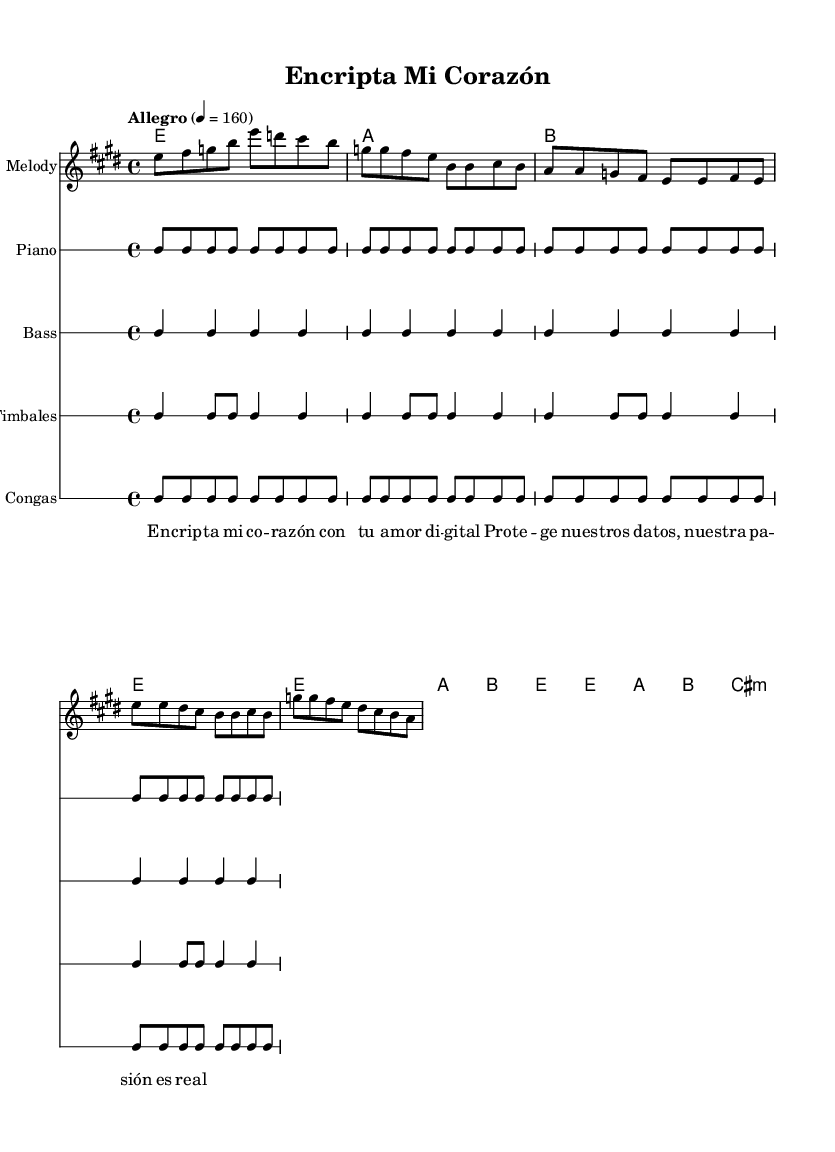What is the key signature of this music? The key signature is shown at the beginning of the piece and indicates E major, which has four sharps.
Answer: E major What is the time signature of the piece? The time signature is located at the start of the music, displaying a '4/4' meaning there are four beats in each measure and the quarter note gets one beat.
Answer: 4/4 What is the tempo marking given for this piece? The tempo marking is found at the beginning, under the header, indicated by "Allegro" and a metronome marking of "4 = 160," which suggests it should be played fast.
Answer: Allegro 4 = 160 How many measures are in the chorus? The chorus section is marked and can be counted from the notation provided; it consists of two measures.
Answer: 2 What type of rhythm is utilized for the congas? The rhythm for the congas is defined in the rhythmic staff dedicated to them and shows a specific pattern that integrates played notes; it follows a repetitive format.
Answer: Conga pattern What thematic element is represented within the lyrics? The lyrics speak about encryption and protection, referring to data safety in the digital era; this theme is reinforced through the use of words like "Encripta" and "Proteger."
Answer: Digital security How does the harmonic structure support the melody? The harmonic structure is evident in the chord changes provided alongside the melody, which complements it by creating the song's full texture and ensuring that changes align with the musical phrases.
Answer: Harmonically aligned 